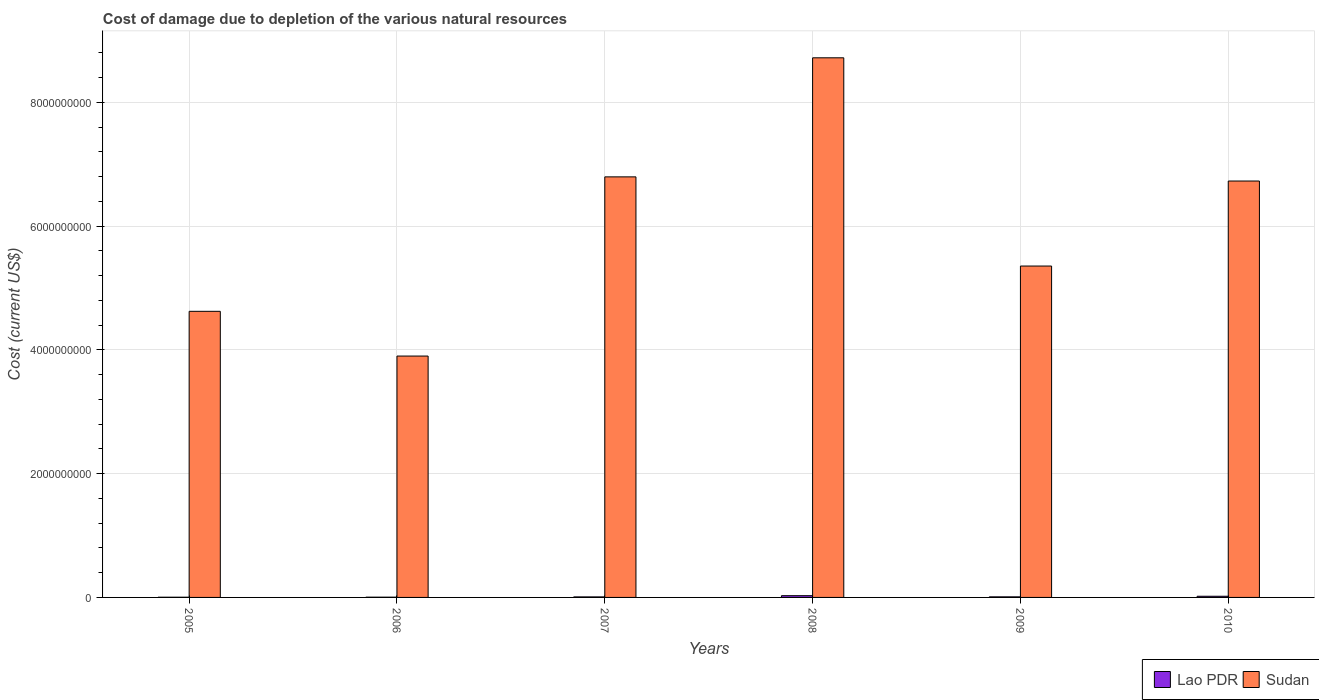How many different coloured bars are there?
Your answer should be compact. 2. Are the number of bars per tick equal to the number of legend labels?
Make the answer very short. Yes. Are the number of bars on each tick of the X-axis equal?
Your response must be concise. Yes. How many bars are there on the 6th tick from the left?
Make the answer very short. 2. How many bars are there on the 1st tick from the right?
Provide a succinct answer. 2. In how many cases, is the number of bars for a given year not equal to the number of legend labels?
Your answer should be compact. 0. What is the cost of damage caused due to the depletion of various natural resources in Sudan in 2006?
Give a very brief answer. 3.90e+09. Across all years, what is the maximum cost of damage caused due to the depletion of various natural resources in Sudan?
Your response must be concise. 8.72e+09. Across all years, what is the minimum cost of damage caused due to the depletion of various natural resources in Sudan?
Offer a very short reply. 3.90e+09. In which year was the cost of damage caused due to the depletion of various natural resources in Lao PDR maximum?
Your response must be concise. 2008. What is the total cost of damage caused due to the depletion of various natural resources in Lao PDR in the graph?
Keep it short and to the point. 7.21e+07. What is the difference between the cost of damage caused due to the depletion of various natural resources in Lao PDR in 2007 and that in 2008?
Ensure brevity in your answer.  -1.96e+07. What is the difference between the cost of damage caused due to the depletion of various natural resources in Sudan in 2007 and the cost of damage caused due to the depletion of various natural resources in Lao PDR in 2005?
Make the answer very short. 6.79e+09. What is the average cost of damage caused due to the depletion of various natural resources in Lao PDR per year?
Provide a short and direct response. 1.20e+07. In the year 2008, what is the difference between the cost of damage caused due to the depletion of various natural resources in Sudan and cost of damage caused due to the depletion of various natural resources in Lao PDR?
Your response must be concise. 8.69e+09. In how many years, is the cost of damage caused due to the depletion of various natural resources in Lao PDR greater than 7200000000 US$?
Ensure brevity in your answer.  0. What is the ratio of the cost of damage caused due to the depletion of various natural resources in Sudan in 2006 to that in 2007?
Offer a very short reply. 0.57. What is the difference between the highest and the second highest cost of damage caused due to the depletion of various natural resources in Sudan?
Your answer should be very brief. 1.92e+09. What is the difference between the highest and the lowest cost of damage caused due to the depletion of various natural resources in Lao PDR?
Your answer should be very brief. 2.50e+07. Is the sum of the cost of damage caused due to the depletion of various natural resources in Sudan in 2005 and 2009 greater than the maximum cost of damage caused due to the depletion of various natural resources in Lao PDR across all years?
Offer a terse response. Yes. What does the 2nd bar from the left in 2008 represents?
Provide a short and direct response. Sudan. What does the 1st bar from the right in 2005 represents?
Give a very brief answer. Sudan. How many bars are there?
Make the answer very short. 12. How many years are there in the graph?
Offer a terse response. 6. Are the values on the major ticks of Y-axis written in scientific E-notation?
Offer a very short reply. No. Where does the legend appear in the graph?
Your response must be concise. Bottom right. How many legend labels are there?
Provide a succinct answer. 2. How are the legend labels stacked?
Ensure brevity in your answer.  Horizontal. What is the title of the graph?
Provide a short and direct response. Cost of damage due to depletion of the various natural resources. What is the label or title of the Y-axis?
Ensure brevity in your answer.  Cost (current US$). What is the Cost (current US$) of Lao PDR in 2005?
Offer a terse response. 3.11e+06. What is the Cost (current US$) of Sudan in 2005?
Offer a very short reply. 4.62e+09. What is the Cost (current US$) in Lao PDR in 2006?
Your answer should be very brief. 4.01e+06. What is the Cost (current US$) of Sudan in 2006?
Ensure brevity in your answer.  3.90e+09. What is the Cost (current US$) in Lao PDR in 2007?
Your response must be concise. 8.51e+06. What is the Cost (current US$) of Sudan in 2007?
Make the answer very short. 6.80e+09. What is the Cost (current US$) in Lao PDR in 2008?
Your answer should be very brief. 2.81e+07. What is the Cost (current US$) in Sudan in 2008?
Your response must be concise. 8.72e+09. What is the Cost (current US$) of Lao PDR in 2009?
Offer a terse response. 9.36e+06. What is the Cost (current US$) of Sudan in 2009?
Provide a short and direct response. 5.36e+09. What is the Cost (current US$) in Lao PDR in 2010?
Your answer should be very brief. 1.90e+07. What is the Cost (current US$) in Sudan in 2010?
Offer a terse response. 6.73e+09. Across all years, what is the maximum Cost (current US$) in Lao PDR?
Offer a terse response. 2.81e+07. Across all years, what is the maximum Cost (current US$) in Sudan?
Provide a short and direct response. 8.72e+09. Across all years, what is the minimum Cost (current US$) of Lao PDR?
Give a very brief answer. 3.11e+06. Across all years, what is the minimum Cost (current US$) of Sudan?
Make the answer very short. 3.90e+09. What is the total Cost (current US$) in Lao PDR in the graph?
Offer a very short reply. 7.21e+07. What is the total Cost (current US$) in Sudan in the graph?
Make the answer very short. 3.61e+1. What is the difference between the Cost (current US$) in Lao PDR in 2005 and that in 2006?
Offer a very short reply. -8.99e+05. What is the difference between the Cost (current US$) in Sudan in 2005 and that in 2006?
Provide a succinct answer. 7.23e+08. What is the difference between the Cost (current US$) of Lao PDR in 2005 and that in 2007?
Keep it short and to the point. -5.40e+06. What is the difference between the Cost (current US$) of Sudan in 2005 and that in 2007?
Your answer should be very brief. -2.17e+09. What is the difference between the Cost (current US$) of Lao PDR in 2005 and that in 2008?
Offer a terse response. -2.50e+07. What is the difference between the Cost (current US$) in Sudan in 2005 and that in 2008?
Your answer should be very brief. -4.10e+09. What is the difference between the Cost (current US$) of Lao PDR in 2005 and that in 2009?
Offer a very short reply. -6.25e+06. What is the difference between the Cost (current US$) of Sudan in 2005 and that in 2009?
Provide a short and direct response. -7.32e+08. What is the difference between the Cost (current US$) of Lao PDR in 2005 and that in 2010?
Your answer should be very brief. -1.59e+07. What is the difference between the Cost (current US$) of Sudan in 2005 and that in 2010?
Offer a very short reply. -2.11e+09. What is the difference between the Cost (current US$) in Lao PDR in 2006 and that in 2007?
Give a very brief answer. -4.50e+06. What is the difference between the Cost (current US$) in Sudan in 2006 and that in 2007?
Provide a succinct answer. -2.90e+09. What is the difference between the Cost (current US$) in Lao PDR in 2006 and that in 2008?
Your answer should be very brief. -2.41e+07. What is the difference between the Cost (current US$) of Sudan in 2006 and that in 2008?
Your answer should be very brief. -4.82e+09. What is the difference between the Cost (current US$) of Lao PDR in 2006 and that in 2009?
Keep it short and to the point. -5.36e+06. What is the difference between the Cost (current US$) of Sudan in 2006 and that in 2009?
Make the answer very short. -1.45e+09. What is the difference between the Cost (current US$) of Lao PDR in 2006 and that in 2010?
Your answer should be compact. -1.50e+07. What is the difference between the Cost (current US$) in Sudan in 2006 and that in 2010?
Provide a short and direct response. -2.83e+09. What is the difference between the Cost (current US$) of Lao PDR in 2007 and that in 2008?
Your answer should be very brief. -1.96e+07. What is the difference between the Cost (current US$) of Sudan in 2007 and that in 2008?
Ensure brevity in your answer.  -1.92e+09. What is the difference between the Cost (current US$) in Lao PDR in 2007 and that in 2009?
Your answer should be very brief. -8.51e+05. What is the difference between the Cost (current US$) in Sudan in 2007 and that in 2009?
Offer a very short reply. 1.44e+09. What is the difference between the Cost (current US$) of Lao PDR in 2007 and that in 2010?
Your answer should be compact. -1.05e+07. What is the difference between the Cost (current US$) of Sudan in 2007 and that in 2010?
Give a very brief answer. 6.72e+07. What is the difference between the Cost (current US$) of Lao PDR in 2008 and that in 2009?
Make the answer very short. 1.87e+07. What is the difference between the Cost (current US$) of Sudan in 2008 and that in 2009?
Ensure brevity in your answer.  3.37e+09. What is the difference between the Cost (current US$) of Lao PDR in 2008 and that in 2010?
Your answer should be compact. 9.12e+06. What is the difference between the Cost (current US$) of Sudan in 2008 and that in 2010?
Ensure brevity in your answer.  1.99e+09. What is the difference between the Cost (current US$) of Lao PDR in 2009 and that in 2010?
Offer a terse response. -9.63e+06. What is the difference between the Cost (current US$) in Sudan in 2009 and that in 2010?
Offer a terse response. -1.37e+09. What is the difference between the Cost (current US$) of Lao PDR in 2005 and the Cost (current US$) of Sudan in 2006?
Offer a terse response. -3.90e+09. What is the difference between the Cost (current US$) in Lao PDR in 2005 and the Cost (current US$) in Sudan in 2007?
Ensure brevity in your answer.  -6.79e+09. What is the difference between the Cost (current US$) of Lao PDR in 2005 and the Cost (current US$) of Sudan in 2008?
Offer a very short reply. -8.72e+09. What is the difference between the Cost (current US$) in Lao PDR in 2005 and the Cost (current US$) in Sudan in 2009?
Offer a terse response. -5.35e+09. What is the difference between the Cost (current US$) in Lao PDR in 2005 and the Cost (current US$) in Sudan in 2010?
Provide a short and direct response. -6.73e+09. What is the difference between the Cost (current US$) of Lao PDR in 2006 and the Cost (current US$) of Sudan in 2007?
Ensure brevity in your answer.  -6.79e+09. What is the difference between the Cost (current US$) in Lao PDR in 2006 and the Cost (current US$) in Sudan in 2008?
Provide a succinct answer. -8.72e+09. What is the difference between the Cost (current US$) of Lao PDR in 2006 and the Cost (current US$) of Sudan in 2009?
Ensure brevity in your answer.  -5.35e+09. What is the difference between the Cost (current US$) in Lao PDR in 2006 and the Cost (current US$) in Sudan in 2010?
Your answer should be compact. -6.73e+09. What is the difference between the Cost (current US$) in Lao PDR in 2007 and the Cost (current US$) in Sudan in 2008?
Ensure brevity in your answer.  -8.71e+09. What is the difference between the Cost (current US$) in Lao PDR in 2007 and the Cost (current US$) in Sudan in 2009?
Provide a succinct answer. -5.35e+09. What is the difference between the Cost (current US$) of Lao PDR in 2007 and the Cost (current US$) of Sudan in 2010?
Your response must be concise. -6.72e+09. What is the difference between the Cost (current US$) of Lao PDR in 2008 and the Cost (current US$) of Sudan in 2009?
Offer a terse response. -5.33e+09. What is the difference between the Cost (current US$) in Lao PDR in 2008 and the Cost (current US$) in Sudan in 2010?
Ensure brevity in your answer.  -6.70e+09. What is the difference between the Cost (current US$) in Lao PDR in 2009 and the Cost (current US$) in Sudan in 2010?
Ensure brevity in your answer.  -6.72e+09. What is the average Cost (current US$) of Lao PDR per year?
Keep it short and to the point. 1.20e+07. What is the average Cost (current US$) of Sudan per year?
Offer a very short reply. 6.02e+09. In the year 2005, what is the difference between the Cost (current US$) of Lao PDR and Cost (current US$) of Sudan?
Offer a terse response. -4.62e+09. In the year 2006, what is the difference between the Cost (current US$) of Lao PDR and Cost (current US$) of Sudan?
Give a very brief answer. -3.90e+09. In the year 2007, what is the difference between the Cost (current US$) in Lao PDR and Cost (current US$) in Sudan?
Keep it short and to the point. -6.79e+09. In the year 2008, what is the difference between the Cost (current US$) of Lao PDR and Cost (current US$) of Sudan?
Provide a short and direct response. -8.69e+09. In the year 2009, what is the difference between the Cost (current US$) of Lao PDR and Cost (current US$) of Sudan?
Offer a very short reply. -5.35e+09. In the year 2010, what is the difference between the Cost (current US$) of Lao PDR and Cost (current US$) of Sudan?
Provide a succinct answer. -6.71e+09. What is the ratio of the Cost (current US$) of Lao PDR in 2005 to that in 2006?
Ensure brevity in your answer.  0.78. What is the ratio of the Cost (current US$) in Sudan in 2005 to that in 2006?
Your answer should be very brief. 1.19. What is the ratio of the Cost (current US$) of Lao PDR in 2005 to that in 2007?
Provide a short and direct response. 0.37. What is the ratio of the Cost (current US$) in Sudan in 2005 to that in 2007?
Offer a very short reply. 0.68. What is the ratio of the Cost (current US$) in Lao PDR in 2005 to that in 2008?
Keep it short and to the point. 0.11. What is the ratio of the Cost (current US$) of Sudan in 2005 to that in 2008?
Your response must be concise. 0.53. What is the ratio of the Cost (current US$) of Lao PDR in 2005 to that in 2009?
Keep it short and to the point. 0.33. What is the ratio of the Cost (current US$) of Sudan in 2005 to that in 2009?
Provide a short and direct response. 0.86. What is the ratio of the Cost (current US$) in Lao PDR in 2005 to that in 2010?
Make the answer very short. 0.16. What is the ratio of the Cost (current US$) in Sudan in 2005 to that in 2010?
Your answer should be very brief. 0.69. What is the ratio of the Cost (current US$) in Lao PDR in 2006 to that in 2007?
Your answer should be very brief. 0.47. What is the ratio of the Cost (current US$) in Sudan in 2006 to that in 2007?
Provide a succinct answer. 0.57. What is the ratio of the Cost (current US$) in Lao PDR in 2006 to that in 2008?
Keep it short and to the point. 0.14. What is the ratio of the Cost (current US$) of Sudan in 2006 to that in 2008?
Your response must be concise. 0.45. What is the ratio of the Cost (current US$) in Lao PDR in 2006 to that in 2009?
Make the answer very short. 0.43. What is the ratio of the Cost (current US$) of Sudan in 2006 to that in 2009?
Your answer should be compact. 0.73. What is the ratio of the Cost (current US$) in Lao PDR in 2006 to that in 2010?
Your answer should be very brief. 0.21. What is the ratio of the Cost (current US$) in Sudan in 2006 to that in 2010?
Provide a short and direct response. 0.58. What is the ratio of the Cost (current US$) in Lao PDR in 2007 to that in 2008?
Keep it short and to the point. 0.3. What is the ratio of the Cost (current US$) of Sudan in 2007 to that in 2008?
Make the answer very short. 0.78. What is the ratio of the Cost (current US$) in Lao PDR in 2007 to that in 2009?
Offer a very short reply. 0.91. What is the ratio of the Cost (current US$) in Sudan in 2007 to that in 2009?
Your answer should be very brief. 1.27. What is the ratio of the Cost (current US$) in Lao PDR in 2007 to that in 2010?
Your answer should be very brief. 0.45. What is the ratio of the Cost (current US$) in Sudan in 2007 to that in 2010?
Ensure brevity in your answer.  1.01. What is the ratio of the Cost (current US$) in Lao PDR in 2008 to that in 2009?
Ensure brevity in your answer.  3. What is the ratio of the Cost (current US$) in Sudan in 2008 to that in 2009?
Provide a short and direct response. 1.63. What is the ratio of the Cost (current US$) of Lao PDR in 2008 to that in 2010?
Ensure brevity in your answer.  1.48. What is the ratio of the Cost (current US$) in Sudan in 2008 to that in 2010?
Make the answer very short. 1.3. What is the ratio of the Cost (current US$) in Lao PDR in 2009 to that in 2010?
Provide a short and direct response. 0.49. What is the ratio of the Cost (current US$) in Sudan in 2009 to that in 2010?
Give a very brief answer. 0.8. What is the difference between the highest and the second highest Cost (current US$) of Lao PDR?
Your answer should be compact. 9.12e+06. What is the difference between the highest and the second highest Cost (current US$) of Sudan?
Your response must be concise. 1.92e+09. What is the difference between the highest and the lowest Cost (current US$) in Lao PDR?
Offer a terse response. 2.50e+07. What is the difference between the highest and the lowest Cost (current US$) of Sudan?
Offer a terse response. 4.82e+09. 